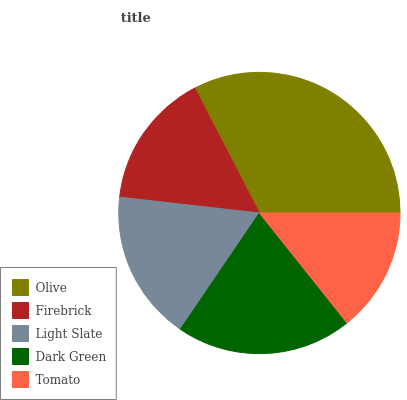Is Tomato the minimum?
Answer yes or no. Yes. Is Olive the maximum?
Answer yes or no. Yes. Is Firebrick the minimum?
Answer yes or no. No. Is Firebrick the maximum?
Answer yes or no. No. Is Olive greater than Firebrick?
Answer yes or no. Yes. Is Firebrick less than Olive?
Answer yes or no. Yes. Is Firebrick greater than Olive?
Answer yes or no. No. Is Olive less than Firebrick?
Answer yes or no. No. Is Light Slate the high median?
Answer yes or no. Yes. Is Light Slate the low median?
Answer yes or no. Yes. Is Dark Green the high median?
Answer yes or no. No. Is Tomato the low median?
Answer yes or no. No. 